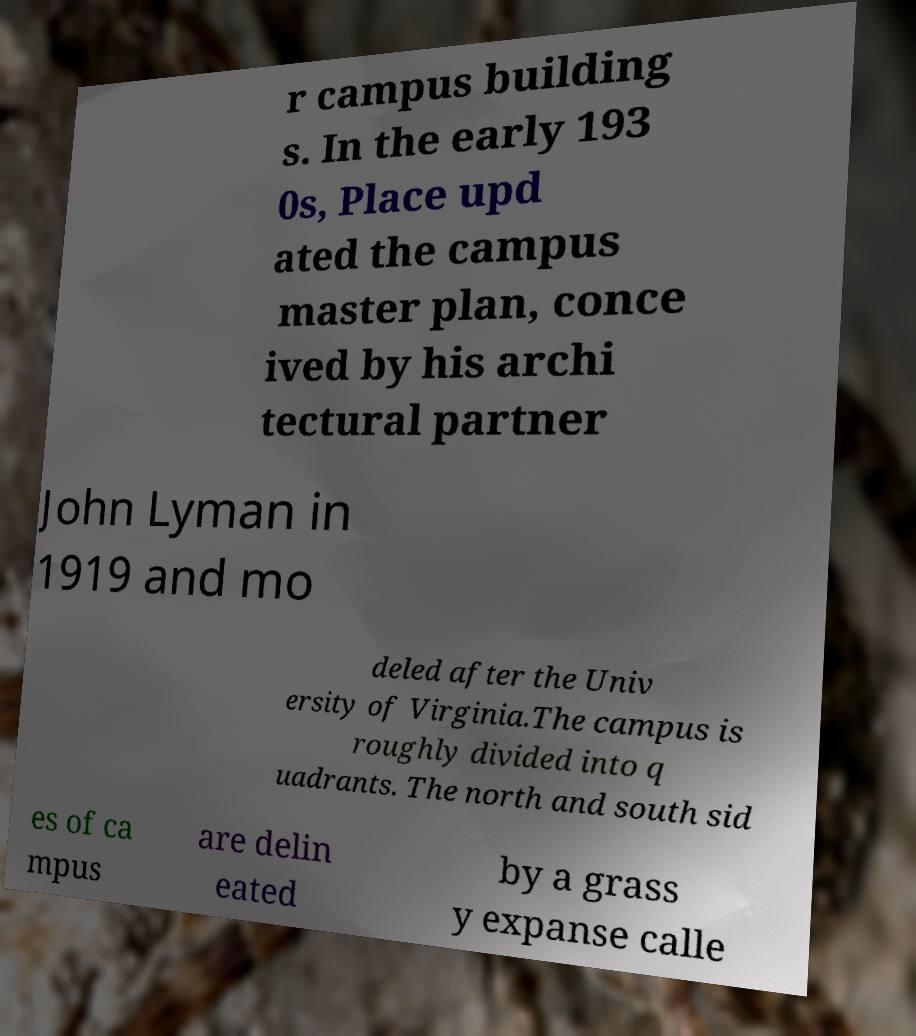Please identify and transcribe the text found in this image. r campus building s. In the early 193 0s, Place upd ated the campus master plan, conce ived by his archi tectural partner John Lyman in 1919 and mo deled after the Univ ersity of Virginia.The campus is roughly divided into q uadrants. The north and south sid es of ca mpus are delin eated by a grass y expanse calle 